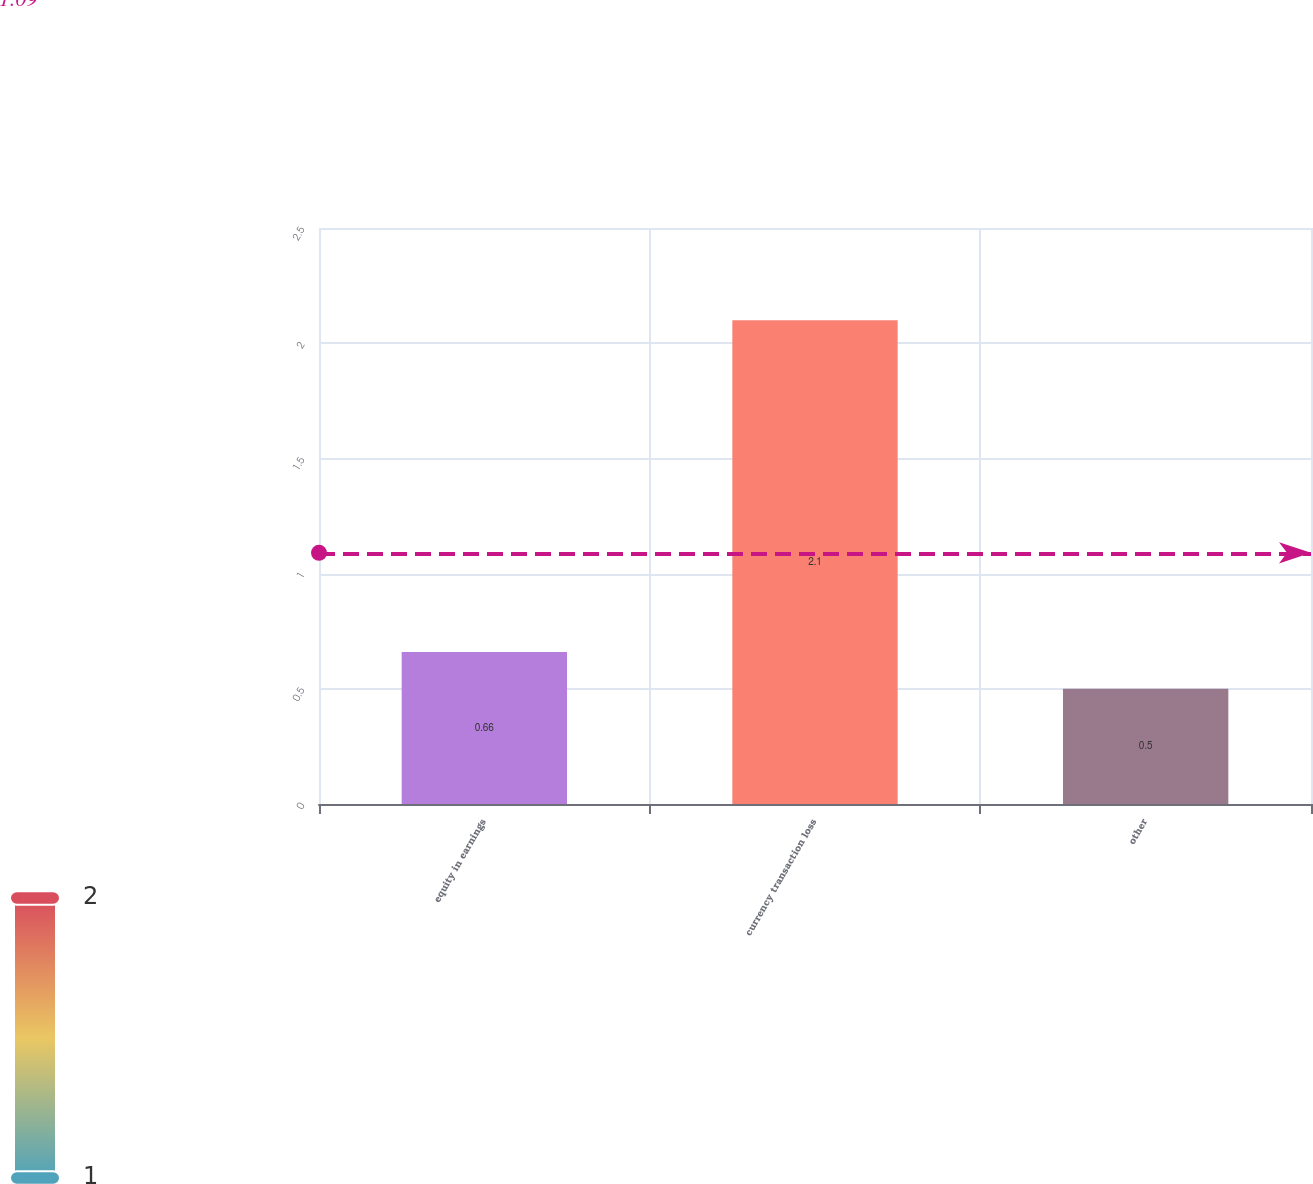Convert chart. <chart><loc_0><loc_0><loc_500><loc_500><bar_chart><fcel>equity in earnings<fcel>currency transaction loss<fcel>other<nl><fcel>0.66<fcel>2.1<fcel>0.5<nl></chart> 